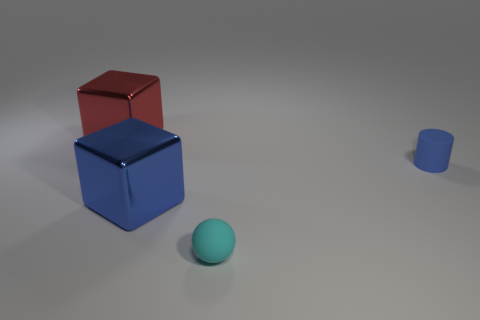Is the color of the tiny matte cylinder the same as the ball?
Offer a very short reply. No. There is another object that is the same shape as the large red shiny thing; what material is it?
Keep it short and to the point. Metal. Is there any other thing that is made of the same material as the cyan thing?
Provide a short and direct response. Yes. Are there the same number of blue cubes behind the large red shiny block and blue metal things that are in front of the cyan matte ball?
Your answer should be very brief. Yes. Is the material of the red thing the same as the ball?
Make the answer very short. No. How many gray objects are either big metal blocks or tiny rubber balls?
Provide a short and direct response. 0. How many other objects are the same shape as the red object?
Your answer should be very brief. 1. What is the large blue thing made of?
Provide a succinct answer. Metal. Are there the same number of blue blocks right of the blue rubber cylinder and red blocks?
Offer a terse response. No. What shape is the object that is the same size as the cyan ball?
Offer a terse response. Cylinder. 